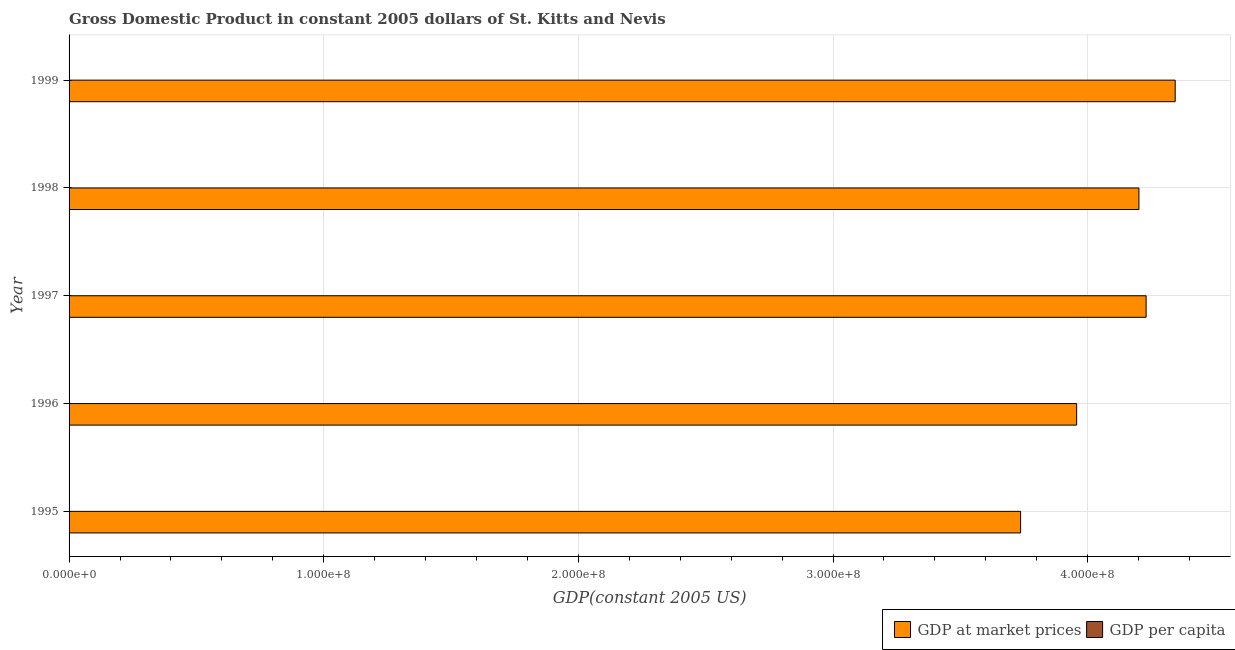Are the number of bars per tick equal to the number of legend labels?
Your response must be concise. Yes. Are the number of bars on each tick of the Y-axis equal?
Give a very brief answer. Yes. What is the gdp per capita in 1997?
Ensure brevity in your answer.  9637.85. Across all years, what is the maximum gdp at market prices?
Keep it short and to the point. 4.34e+08. Across all years, what is the minimum gdp at market prices?
Provide a short and direct response. 3.74e+08. In which year was the gdp per capita maximum?
Give a very brief answer. 1999. In which year was the gdp at market prices minimum?
Your response must be concise. 1995. What is the total gdp at market prices in the graph?
Keep it short and to the point. 2.05e+09. What is the difference between the gdp per capita in 1997 and that in 1999?
Give a very brief answer. -28.15. What is the difference between the gdp per capita in 1995 and the gdp at market prices in 1997?
Offer a terse response. -4.23e+08. What is the average gdp at market prices per year?
Give a very brief answer. 4.09e+08. In the year 1999, what is the difference between the gdp per capita and gdp at market prices?
Your answer should be compact. -4.34e+08. In how many years, is the gdp at market prices greater than 160000000 US$?
Provide a succinct answer. 5. What is the ratio of the gdp per capita in 1995 to that in 1996?
Offer a terse response. 0.95. Is the gdp at market prices in 1995 less than that in 1998?
Ensure brevity in your answer.  Yes. What is the difference between the highest and the second highest gdp per capita?
Make the answer very short. 28.15. What is the difference between the highest and the lowest gdp at market prices?
Give a very brief answer. 6.07e+07. Is the sum of the gdp at market prices in 1995 and 1999 greater than the maximum gdp per capita across all years?
Your answer should be very brief. Yes. What does the 2nd bar from the top in 1995 represents?
Offer a very short reply. GDP at market prices. What does the 1st bar from the bottom in 1998 represents?
Provide a succinct answer. GDP at market prices. Are all the bars in the graph horizontal?
Your answer should be very brief. Yes. What is the difference between two consecutive major ticks on the X-axis?
Offer a very short reply. 1.00e+08. Are the values on the major ticks of X-axis written in scientific E-notation?
Your answer should be very brief. Yes. Does the graph contain any zero values?
Your answer should be compact. No. How many legend labels are there?
Your answer should be compact. 2. What is the title of the graph?
Ensure brevity in your answer.  Gross Domestic Product in constant 2005 dollars of St. Kitts and Nevis. What is the label or title of the X-axis?
Keep it short and to the point. GDP(constant 2005 US). What is the label or title of the Y-axis?
Provide a succinct answer. Year. What is the GDP(constant 2005 US) in GDP at market prices in 1995?
Offer a very short reply. 3.74e+08. What is the GDP(constant 2005 US) of GDP per capita in 1995?
Ensure brevity in your answer.  8712.81. What is the GDP(constant 2005 US) of GDP at market prices in 1996?
Your response must be concise. 3.96e+08. What is the GDP(constant 2005 US) in GDP per capita in 1996?
Offer a very short reply. 9118.72. What is the GDP(constant 2005 US) in GDP at market prices in 1997?
Your answer should be very brief. 4.23e+08. What is the GDP(constant 2005 US) in GDP per capita in 1997?
Provide a short and direct response. 9637.85. What is the GDP(constant 2005 US) in GDP at market prices in 1998?
Provide a succinct answer. 4.20e+08. What is the GDP(constant 2005 US) in GDP per capita in 1998?
Your response must be concise. 9464.41. What is the GDP(constant 2005 US) of GDP at market prices in 1999?
Ensure brevity in your answer.  4.34e+08. What is the GDP(constant 2005 US) in GDP per capita in 1999?
Provide a succinct answer. 9666. Across all years, what is the maximum GDP(constant 2005 US) in GDP at market prices?
Give a very brief answer. 4.34e+08. Across all years, what is the maximum GDP(constant 2005 US) in GDP per capita?
Your response must be concise. 9666. Across all years, what is the minimum GDP(constant 2005 US) of GDP at market prices?
Provide a short and direct response. 3.74e+08. Across all years, what is the minimum GDP(constant 2005 US) of GDP per capita?
Provide a succinct answer. 8712.81. What is the total GDP(constant 2005 US) of GDP at market prices in the graph?
Your answer should be compact. 2.05e+09. What is the total GDP(constant 2005 US) of GDP per capita in the graph?
Your response must be concise. 4.66e+04. What is the difference between the GDP(constant 2005 US) in GDP at market prices in 1995 and that in 1996?
Ensure brevity in your answer.  -2.20e+07. What is the difference between the GDP(constant 2005 US) in GDP per capita in 1995 and that in 1996?
Make the answer very short. -405.9. What is the difference between the GDP(constant 2005 US) of GDP at market prices in 1995 and that in 1997?
Provide a succinct answer. -4.93e+07. What is the difference between the GDP(constant 2005 US) of GDP per capita in 1995 and that in 1997?
Offer a terse response. -925.04. What is the difference between the GDP(constant 2005 US) in GDP at market prices in 1995 and that in 1998?
Provide a succinct answer. -4.65e+07. What is the difference between the GDP(constant 2005 US) in GDP per capita in 1995 and that in 1998?
Offer a very short reply. -751.6. What is the difference between the GDP(constant 2005 US) of GDP at market prices in 1995 and that in 1999?
Ensure brevity in your answer.  -6.07e+07. What is the difference between the GDP(constant 2005 US) of GDP per capita in 1995 and that in 1999?
Provide a short and direct response. -953.19. What is the difference between the GDP(constant 2005 US) in GDP at market prices in 1996 and that in 1997?
Give a very brief answer. -2.73e+07. What is the difference between the GDP(constant 2005 US) in GDP per capita in 1996 and that in 1997?
Your answer should be compact. -519.13. What is the difference between the GDP(constant 2005 US) of GDP at market prices in 1996 and that in 1998?
Your answer should be very brief. -2.45e+07. What is the difference between the GDP(constant 2005 US) of GDP per capita in 1996 and that in 1998?
Provide a succinct answer. -345.69. What is the difference between the GDP(constant 2005 US) in GDP at market prices in 1996 and that in 1999?
Provide a short and direct response. -3.87e+07. What is the difference between the GDP(constant 2005 US) in GDP per capita in 1996 and that in 1999?
Your response must be concise. -547.29. What is the difference between the GDP(constant 2005 US) of GDP at market prices in 1997 and that in 1998?
Your answer should be compact. 2.82e+06. What is the difference between the GDP(constant 2005 US) in GDP per capita in 1997 and that in 1998?
Your answer should be very brief. 173.44. What is the difference between the GDP(constant 2005 US) of GDP at market prices in 1997 and that in 1999?
Offer a very short reply. -1.14e+07. What is the difference between the GDP(constant 2005 US) of GDP per capita in 1997 and that in 1999?
Offer a very short reply. -28.15. What is the difference between the GDP(constant 2005 US) of GDP at market prices in 1998 and that in 1999?
Your response must be concise. -1.42e+07. What is the difference between the GDP(constant 2005 US) of GDP per capita in 1998 and that in 1999?
Keep it short and to the point. -201.59. What is the difference between the GDP(constant 2005 US) of GDP at market prices in 1995 and the GDP(constant 2005 US) of GDP per capita in 1996?
Ensure brevity in your answer.  3.74e+08. What is the difference between the GDP(constant 2005 US) of GDP at market prices in 1995 and the GDP(constant 2005 US) of GDP per capita in 1997?
Your answer should be compact. 3.74e+08. What is the difference between the GDP(constant 2005 US) of GDP at market prices in 1995 and the GDP(constant 2005 US) of GDP per capita in 1998?
Give a very brief answer. 3.74e+08. What is the difference between the GDP(constant 2005 US) in GDP at market prices in 1995 and the GDP(constant 2005 US) in GDP per capita in 1999?
Give a very brief answer. 3.74e+08. What is the difference between the GDP(constant 2005 US) in GDP at market prices in 1996 and the GDP(constant 2005 US) in GDP per capita in 1997?
Provide a succinct answer. 3.96e+08. What is the difference between the GDP(constant 2005 US) of GDP at market prices in 1996 and the GDP(constant 2005 US) of GDP per capita in 1998?
Your answer should be very brief. 3.96e+08. What is the difference between the GDP(constant 2005 US) of GDP at market prices in 1996 and the GDP(constant 2005 US) of GDP per capita in 1999?
Your response must be concise. 3.96e+08. What is the difference between the GDP(constant 2005 US) of GDP at market prices in 1997 and the GDP(constant 2005 US) of GDP per capita in 1998?
Keep it short and to the point. 4.23e+08. What is the difference between the GDP(constant 2005 US) of GDP at market prices in 1997 and the GDP(constant 2005 US) of GDP per capita in 1999?
Provide a succinct answer. 4.23e+08. What is the difference between the GDP(constant 2005 US) in GDP at market prices in 1998 and the GDP(constant 2005 US) in GDP per capita in 1999?
Give a very brief answer. 4.20e+08. What is the average GDP(constant 2005 US) in GDP at market prices per year?
Your answer should be very brief. 4.09e+08. What is the average GDP(constant 2005 US) in GDP per capita per year?
Provide a short and direct response. 9319.96. In the year 1995, what is the difference between the GDP(constant 2005 US) of GDP at market prices and GDP(constant 2005 US) of GDP per capita?
Keep it short and to the point. 3.74e+08. In the year 1996, what is the difference between the GDP(constant 2005 US) of GDP at market prices and GDP(constant 2005 US) of GDP per capita?
Provide a short and direct response. 3.96e+08. In the year 1997, what is the difference between the GDP(constant 2005 US) of GDP at market prices and GDP(constant 2005 US) of GDP per capita?
Provide a short and direct response. 4.23e+08. In the year 1998, what is the difference between the GDP(constant 2005 US) of GDP at market prices and GDP(constant 2005 US) of GDP per capita?
Give a very brief answer. 4.20e+08. In the year 1999, what is the difference between the GDP(constant 2005 US) in GDP at market prices and GDP(constant 2005 US) in GDP per capita?
Offer a terse response. 4.34e+08. What is the ratio of the GDP(constant 2005 US) of GDP per capita in 1995 to that in 1996?
Provide a short and direct response. 0.96. What is the ratio of the GDP(constant 2005 US) in GDP at market prices in 1995 to that in 1997?
Your response must be concise. 0.88. What is the ratio of the GDP(constant 2005 US) of GDP per capita in 1995 to that in 1997?
Provide a short and direct response. 0.9. What is the ratio of the GDP(constant 2005 US) in GDP at market prices in 1995 to that in 1998?
Offer a very short reply. 0.89. What is the ratio of the GDP(constant 2005 US) in GDP per capita in 1995 to that in 1998?
Your answer should be very brief. 0.92. What is the ratio of the GDP(constant 2005 US) in GDP at market prices in 1995 to that in 1999?
Provide a short and direct response. 0.86. What is the ratio of the GDP(constant 2005 US) of GDP per capita in 1995 to that in 1999?
Make the answer very short. 0.9. What is the ratio of the GDP(constant 2005 US) in GDP at market prices in 1996 to that in 1997?
Provide a short and direct response. 0.94. What is the ratio of the GDP(constant 2005 US) in GDP per capita in 1996 to that in 1997?
Keep it short and to the point. 0.95. What is the ratio of the GDP(constant 2005 US) of GDP at market prices in 1996 to that in 1998?
Give a very brief answer. 0.94. What is the ratio of the GDP(constant 2005 US) of GDP per capita in 1996 to that in 1998?
Give a very brief answer. 0.96. What is the ratio of the GDP(constant 2005 US) of GDP at market prices in 1996 to that in 1999?
Offer a terse response. 0.91. What is the ratio of the GDP(constant 2005 US) of GDP per capita in 1996 to that in 1999?
Offer a very short reply. 0.94. What is the ratio of the GDP(constant 2005 US) in GDP at market prices in 1997 to that in 1998?
Ensure brevity in your answer.  1.01. What is the ratio of the GDP(constant 2005 US) of GDP per capita in 1997 to that in 1998?
Provide a short and direct response. 1.02. What is the ratio of the GDP(constant 2005 US) in GDP at market prices in 1997 to that in 1999?
Your response must be concise. 0.97. What is the ratio of the GDP(constant 2005 US) in GDP at market prices in 1998 to that in 1999?
Offer a very short reply. 0.97. What is the ratio of the GDP(constant 2005 US) of GDP per capita in 1998 to that in 1999?
Provide a succinct answer. 0.98. What is the difference between the highest and the second highest GDP(constant 2005 US) of GDP at market prices?
Provide a succinct answer. 1.14e+07. What is the difference between the highest and the second highest GDP(constant 2005 US) of GDP per capita?
Provide a short and direct response. 28.15. What is the difference between the highest and the lowest GDP(constant 2005 US) in GDP at market prices?
Ensure brevity in your answer.  6.07e+07. What is the difference between the highest and the lowest GDP(constant 2005 US) of GDP per capita?
Give a very brief answer. 953.19. 